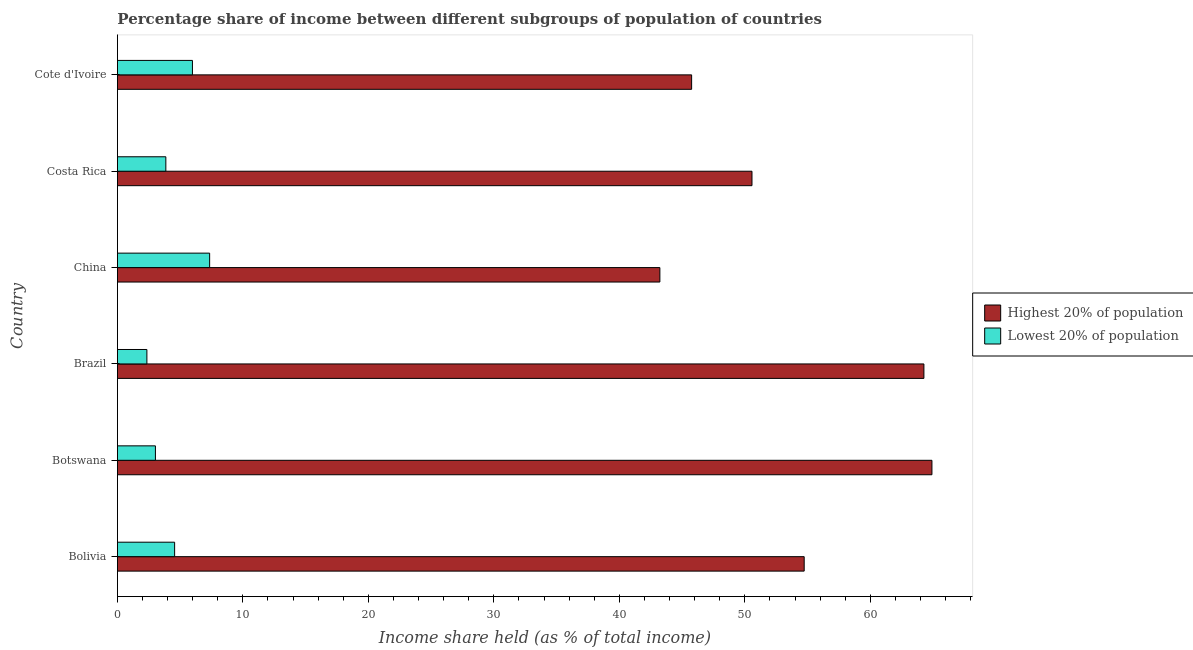How many different coloured bars are there?
Your response must be concise. 2. What is the income share held by highest 20% of the population in China?
Give a very brief answer. 43.23. Across all countries, what is the maximum income share held by lowest 20% of the population?
Ensure brevity in your answer.  7.35. Across all countries, what is the minimum income share held by highest 20% of the population?
Give a very brief answer. 43.23. In which country was the income share held by highest 20% of the population maximum?
Ensure brevity in your answer.  Botswana. What is the total income share held by highest 20% of the population in the graph?
Your answer should be very brief. 323.47. What is the difference between the income share held by lowest 20% of the population in Costa Rica and that in Cote d'Ivoire?
Your answer should be very brief. -2.12. What is the difference between the income share held by highest 20% of the population in Botswana and the income share held by lowest 20% of the population in Brazil?
Your answer should be compact. 62.56. What is the average income share held by lowest 20% of the population per country?
Ensure brevity in your answer.  4.52. What is the difference between the income share held by highest 20% of the population and income share held by lowest 20% of the population in Bolivia?
Your answer should be compact. 50.17. In how many countries, is the income share held by highest 20% of the population greater than 62 %?
Offer a terse response. 2. What is the ratio of the income share held by lowest 20% of the population in Bolivia to that in Brazil?
Offer a very short reply. 1.94. What is the difference between the highest and the second highest income share held by highest 20% of the population?
Provide a succinct answer. 0.64. What is the difference between the highest and the lowest income share held by highest 20% of the population?
Provide a succinct answer. 21.68. In how many countries, is the income share held by highest 20% of the population greater than the average income share held by highest 20% of the population taken over all countries?
Make the answer very short. 3. Is the sum of the income share held by lowest 20% of the population in Bolivia and Brazil greater than the maximum income share held by highest 20% of the population across all countries?
Your answer should be compact. No. What does the 2nd bar from the top in Cote d'Ivoire represents?
Make the answer very short. Highest 20% of population. What does the 2nd bar from the bottom in Bolivia represents?
Offer a terse response. Lowest 20% of population. How many bars are there?
Ensure brevity in your answer.  12. What is the difference between two consecutive major ticks on the X-axis?
Make the answer very short. 10. Are the values on the major ticks of X-axis written in scientific E-notation?
Your response must be concise. No. What is the title of the graph?
Provide a short and direct response. Percentage share of income between different subgroups of population of countries. What is the label or title of the X-axis?
Offer a terse response. Income share held (as % of total income). What is the Income share held (as % of total income) of Highest 20% of population in Bolivia?
Your response must be concise. 54.73. What is the Income share held (as % of total income) in Lowest 20% of population in Bolivia?
Your response must be concise. 4.56. What is the Income share held (as % of total income) of Highest 20% of population in Botswana?
Ensure brevity in your answer.  64.91. What is the Income share held (as % of total income) of Lowest 20% of population in Botswana?
Provide a succinct answer. 3.03. What is the Income share held (as % of total income) of Highest 20% of population in Brazil?
Your answer should be compact. 64.27. What is the Income share held (as % of total income) of Lowest 20% of population in Brazil?
Offer a terse response. 2.35. What is the Income share held (as % of total income) in Highest 20% of population in China?
Give a very brief answer. 43.23. What is the Income share held (as % of total income) of Lowest 20% of population in China?
Make the answer very short. 7.35. What is the Income share held (as % of total income) in Highest 20% of population in Costa Rica?
Provide a succinct answer. 50.57. What is the Income share held (as % of total income) of Lowest 20% of population in Costa Rica?
Ensure brevity in your answer.  3.86. What is the Income share held (as % of total income) of Highest 20% of population in Cote d'Ivoire?
Ensure brevity in your answer.  45.76. What is the Income share held (as % of total income) in Lowest 20% of population in Cote d'Ivoire?
Your answer should be very brief. 5.98. Across all countries, what is the maximum Income share held (as % of total income) in Highest 20% of population?
Your answer should be very brief. 64.91. Across all countries, what is the maximum Income share held (as % of total income) in Lowest 20% of population?
Make the answer very short. 7.35. Across all countries, what is the minimum Income share held (as % of total income) in Highest 20% of population?
Offer a terse response. 43.23. Across all countries, what is the minimum Income share held (as % of total income) in Lowest 20% of population?
Offer a terse response. 2.35. What is the total Income share held (as % of total income) in Highest 20% of population in the graph?
Provide a succinct answer. 323.47. What is the total Income share held (as % of total income) in Lowest 20% of population in the graph?
Ensure brevity in your answer.  27.13. What is the difference between the Income share held (as % of total income) of Highest 20% of population in Bolivia and that in Botswana?
Offer a very short reply. -10.18. What is the difference between the Income share held (as % of total income) in Lowest 20% of population in Bolivia and that in Botswana?
Your response must be concise. 1.53. What is the difference between the Income share held (as % of total income) in Highest 20% of population in Bolivia and that in Brazil?
Provide a succinct answer. -9.54. What is the difference between the Income share held (as % of total income) in Lowest 20% of population in Bolivia and that in Brazil?
Provide a short and direct response. 2.21. What is the difference between the Income share held (as % of total income) in Highest 20% of population in Bolivia and that in China?
Provide a short and direct response. 11.5. What is the difference between the Income share held (as % of total income) in Lowest 20% of population in Bolivia and that in China?
Your response must be concise. -2.79. What is the difference between the Income share held (as % of total income) in Highest 20% of population in Bolivia and that in Costa Rica?
Give a very brief answer. 4.16. What is the difference between the Income share held (as % of total income) in Lowest 20% of population in Bolivia and that in Costa Rica?
Your answer should be compact. 0.7. What is the difference between the Income share held (as % of total income) in Highest 20% of population in Bolivia and that in Cote d'Ivoire?
Offer a terse response. 8.97. What is the difference between the Income share held (as % of total income) of Lowest 20% of population in Bolivia and that in Cote d'Ivoire?
Make the answer very short. -1.42. What is the difference between the Income share held (as % of total income) in Highest 20% of population in Botswana and that in Brazil?
Provide a short and direct response. 0.64. What is the difference between the Income share held (as % of total income) of Lowest 20% of population in Botswana and that in Brazil?
Provide a succinct answer. 0.68. What is the difference between the Income share held (as % of total income) in Highest 20% of population in Botswana and that in China?
Your answer should be very brief. 21.68. What is the difference between the Income share held (as % of total income) in Lowest 20% of population in Botswana and that in China?
Your response must be concise. -4.32. What is the difference between the Income share held (as % of total income) in Highest 20% of population in Botswana and that in Costa Rica?
Make the answer very short. 14.34. What is the difference between the Income share held (as % of total income) of Lowest 20% of population in Botswana and that in Costa Rica?
Provide a short and direct response. -0.83. What is the difference between the Income share held (as % of total income) in Highest 20% of population in Botswana and that in Cote d'Ivoire?
Offer a very short reply. 19.15. What is the difference between the Income share held (as % of total income) in Lowest 20% of population in Botswana and that in Cote d'Ivoire?
Make the answer very short. -2.95. What is the difference between the Income share held (as % of total income) in Highest 20% of population in Brazil and that in China?
Provide a succinct answer. 21.04. What is the difference between the Income share held (as % of total income) in Lowest 20% of population in Brazil and that in China?
Provide a short and direct response. -5. What is the difference between the Income share held (as % of total income) in Lowest 20% of population in Brazil and that in Costa Rica?
Make the answer very short. -1.51. What is the difference between the Income share held (as % of total income) in Highest 20% of population in Brazil and that in Cote d'Ivoire?
Offer a very short reply. 18.51. What is the difference between the Income share held (as % of total income) of Lowest 20% of population in Brazil and that in Cote d'Ivoire?
Your answer should be very brief. -3.63. What is the difference between the Income share held (as % of total income) of Highest 20% of population in China and that in Costa Rica?
Provide a short and direct response. -7.34. What is the difference between the Income share held (as % of total income) in Lowest 20% of population in China and that in Costa Rica?
Provide a succinct answer. 3.49. What is the difference between the Income share held (as % of total income) in Highest 20% of population in China and that in Cote d'Ivoire?
Your response must be concise. -2.53. What is the difference between the Income share held (as % of total income) in Lowest 20% of population in China and that in Cote d'Ivoire?
Your answer should be very brief. 1.37. What is the difference between the Income share held (as % of total income) of Highest 20% of population in Costa Rica and that in Cote d'Ivoire?
Your answer should be compact. 4.81. What is the difference between the Income share held (as % of total income) of Lowest 20% of population in Costa Rica and that in Cote d'Ivoire?
Ensure brevity in your answer.  -2.12. What is the difference between the Income share held (as % of total income) of Highest 20% of population in Bolivia and the Income share held (as % of total income) of Lowest 20% of population in Botswana?
Provide a succinct answer. 51.7. What is the difference between the Income share held (as % of total income) in Highest 20% of population in Bolivia and the Income share held (as % of total income) in Lowest 20% of population in Brazil?
Ensure brevity in your answer.  52.38. What is the difference between the Income share held (as % of total income) of Highest 20% of population in Bolivia and the Income share held (as % of total income) of Lowest 20% of population in China?
Your answer should be very brief. 47.38. What is the difference between the Income share held (as % of total income) in Highest 20% of population in Bolivia and the Income share held (as % of total income) in Lowest 20% of population in Costa Rica?
Make the answer very short. 50.87. What is the difference between the Income share held (as % of total income) in Highest 20% of population in Bolivia and the Income share held (as % of total income) in Lowest 20% of population in Cote d'Ivoire?
Ensure brevity in your answer.  48.75. What is the difference between the Income share held (as % of total income) of Highest 20% of population in Botswana and the Income share held (as % of total income) of Lowest 20% of population in Brazil?
Your response must be concise. 62.56. What is the difference between the Income share held (as % of total income) in Highest 20% of population in Botswana and the Income share held (as % of total income) in Lowest 20% of population in China?
Your answer should be very brief. 57.56. What is the difference between the Income share held (as % of total income) of Highest 20% of population in Botswana and the Income share held (as % of total income) of Lowest 20% of population in Costa Rica?
Offer a very short reply. 61.05. What is the difference between the Income share held (as % of total income) in Highest 20% of population in Botswana and the Income share held (as % of total income) in Lowest 20% of population in Cote d'Ivoire?
Offer a very short reply. 58.93. What is the difference between the Income share held (as % of total income) in Highest 20% of population in Brazil and the Income share held (as % of total income) in Lowest 20% of population in China?
Provide a succinct answer. 56.92. What is the difference between the Income share held (as % of total income) in Highest 20% of population in Brazil and the Income share held (as % of total income) in Lowest 20% of population in Costa Rica?
Provide a short and direct response. 60.41. What is the difference between the Income share held (as % of total income) in Highest 20% of population in Brazil and the Income share held (as % of total income) in Lowest 20% of population in Cote d'Ivoire?
Make the answer very short. 58.29. What is the difference between the Income share held (as % of total income) in Highest 20% of population in China and the Income share held (as % of total income) in Lowest 20% of population in Costa Rica?
Your response must be concise. 39.37. What is the difference between the Income share held (as % of total income) of Highest 20% of population in China and the Income share held (as % of total income) of Lowest 20% of population in Cote d'Ivoire?
Offer a very short reply. 37.25. What is the difference between the Income share held (as % of total income) in Highest 20% of population in Costa Rica and the Income share held (as % of total income) in Lowest 20% of population in Cote d'Ivoire?
Ensure brevity in your answer.  44.59. What is the average Income share held (as % of total income) in Highest 20% of population per country?
Your response must be concise. 53.91. What is the average Income share held (as % of total income) in Lowest 20% of population per country?
Ensure brevity in your answer.  4.52. What is the difference between the Income share held (as % of total income) of Highest 20% of population and Income share held (as % of total income) of Lowest 20% of population in Bolivia?
Offer a very short reply. 50.17. What is the difference between the Income share held (as % of total income) of Highest 20% of population and Income share held (as % of total income) of Lowest 20% of population in Botswana?
Ensure brevity in your answer.  61.88. What is the difference between the Income share held (as % of total income) of Highest 20% of population and Income share held (as % of total income) of Lowest 20% of population in Brazil?
Provide a succinct answer. 61.92. What is the difference between the Income share held (as % of total income) of Highest 20% of population and Income share held (as % of total income) of Lowest 20% of population in China?
Your answer should be very brief. 35.88. What is the difference between the Income share held (as % of total income) in Highest 20% of population and Income share held (as % of total income) in Lowest 20% of population in Costa Rica?
Keep it short and to the point. 46.71. What is the difference between the Income share held (as % of total income) in Highest 20% of population and Income share held (as % of total income) in Lowest 20% of population in Cote d'Ivoire?
Provide a short and direct response. 39.78. What is the ratio of the Income share held (as % of total income) in Highest 20% of population in Bolivia to that in Botswana?
Provide a succinct answer. 0.84. What is the ratio of the Income share held (as % of total income) in Lowest 20% of population in Bolivia to that in Botswana?
Make the answer very short. 1.5. What is the ratio of the Income share held (as % of total income) in Highest 20% of population in Bolivia to that in Brazil?
Keep it short and to the point. 0.85. What is the ratio of the Income share held (as % of total income) in Lowest 20% of population in Bolivia to that in Brazil?
Provide a succinct answer. 1.94. What is the ratio of the Income share held (as % of total income) in Highest 20% of population in Bolivia to that in China?
Your answer should be compact. 1.27. What is the ratio of the Income share held (as % of total income) of Lowest 20% of population in Bolivia to that in China?
Your answer should be compact. 0.62. What is the ratio of the Income share held (as % of total income) in Highest 20% of population in Bolivia to that in Costa Rica?
Offer a terse response. 1.08. What is the ratio of the Income share held (as % of total income) in Lowest 20% of population in Bolivia to that in Costa Rica?
Offer a very short reply. 1.18. What is the ratio of the Income share held (as % of total income) of Highest 20% of population in Bolivia to that in Cote d'Ivoire?
Give a very brief answer. 1.2. What is the ratio of the Income share held (as % of total income) of Lowest 20% of population in Bolivia to that in Cote d'Ivoire?
Offer a very short reply. 0.76. What is the ratio of the Income share held (as % of total income) in Highest 20% of population in Botswana to that in Brazil?
Ensure brevity in your answer.  1.01. What is the ratio of the Income share held (as % of total income) of Lowest 20% of population in Botswana to that in Brazil?
Offer a terse response. 1.29. What is the ratio of the Income share held (as % of total income) in Highest 20% of population in Botswana to that in China?
Your answer should be very brief. 1.5. What is the ratio of the Income share held (as % of total income) of Lowest 20% of population in Botswana to that in China?
Offer a very short reply. 0.41. What is the ratio of the Income share held (as % of total income) in Highest 20% of population in Botswana to that in Costa Rica?
Your answer should be compact. 1.28. What is the ratio of the Income share held (as % of total income) of Lowest 20% of population in Botswana to that in Costa Rica?
Provide a short and direct response. 0.79. What is the ratio of the Income share held (as % of total income) of Highest 20% of population in Botswana to that in Cote d'Ivoire?
Provide a short and direct response. 1.42. What is the ratio of the Income share held (as % of total income) of Lowest 20% of population in Botswana to that in Cote d'Ivoire?
Offer a terse response. 0.51. What is the ratio of the Income share held (as % of total income) in Highest 20% of population in Brazil to that in China?
Your answer should be very brief. 1.49. What is the ratio of the Income share held (as % of total income) of Lowest 20% of population in Brazil to that in China?
Your response must be concise. 0.32. What is the ratio of the Income share held (as % of total income) of Highest 20% of population in Brazil to that in Costa Rica?
Offer a terse response. 1.27. What is the ratio of the Income share held (as % of total income) of Lowest 20% of population in Brazil to that in Costa Rica?
Your answer should be compact. 0.61. What is the ratio of the Income share held (as % of total income) of Highest 20% of population in Brazil to that in Cote d'Ivoire?
Give a very brief answer. 1.4. What is the ratio of the Income share held (as % of total income) of Lowest 20% of population in Brazil to that in Cote d'Ivoire?
Make the answer very short. 0.39. What is the ratio of the Income share held (as % of total income) in Highest 20% of population in China to that in Costa Rica?
Your response must be concise. 0.85. What is the ratio of the Income share held (as % of total income) in Lowest 20% of population in China to that in Costa Rica?
Provide a short and direct response. 1.9. What is the ratio of the Income share held (as % of total income) in Highest 20% of population in China to that in Cote d'Ivoire?
Offer a terse response. 0.94. What is the ratio of the Income share held (as % of total income) of Lowest 20% of population in China to that in Cote d'Ivoire?
Provide a succinct answer. 1.23. What is the ratio of the Income share held (as % of total income) of Highest 20% of population in Costa Rica to that in Cote d'Ivoire?
Offer a very short reply. 1.11. What is the ratio of the Income share held (as % of total income) of Lowest 20% of population in Costa Rica to that in Cote d'Ivoire?
Offer a terse response. 0.65. What is the difference between the highest and the second highest Income share held (as % of total income) of Highest 20% of population?
Offer a terse response. 0.64. What is the difference between the highest and the second highest Income share held (as % of total income) in Lowest 20% of population?
Ensure brevity in your answer.  1.37. What is the difference between the highest and the lowest Income share held (as % of total income) of Highest 20% of population?
Offer a very short reply. 21.68. What is the difference between the highest and the lowest Income share held (as % of total income) in Lowest 20% of population?
Make the answer very short. 5. 